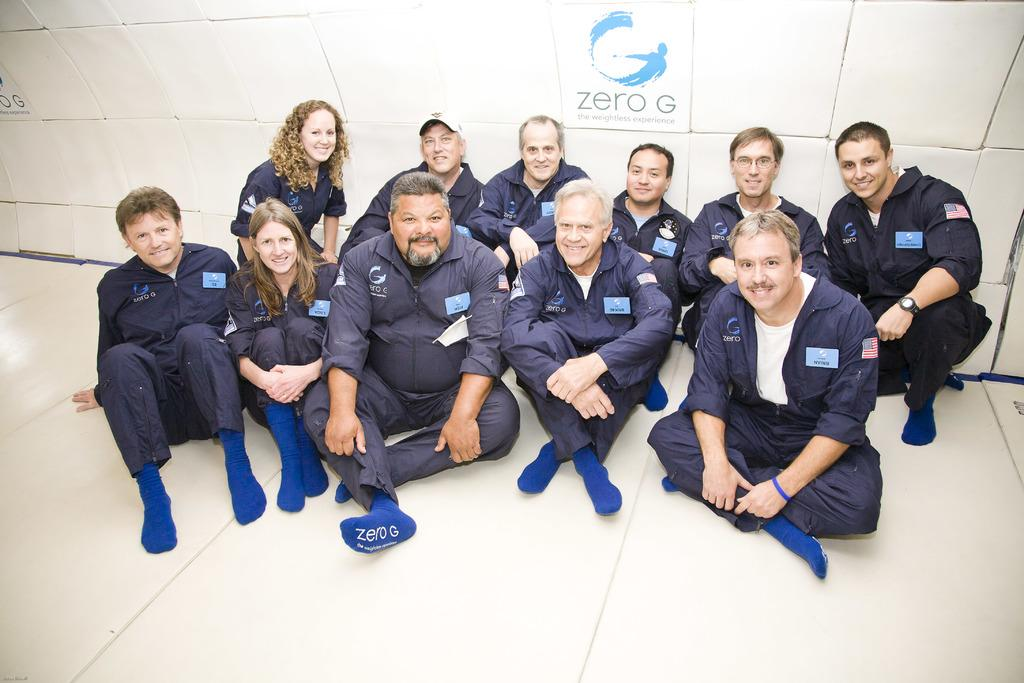How many people are in the image? There are persons in the image, but the exact number is not specified. What are the persons wearing? The persons are wearing clothes. Where are the persons sitting? The persons are sitting in front of a wall. What is at the top of the image? There is a board at the top of the image. What type of plant is growing on the wall behind the persons? There is no plant visible in the image; the persons are sitting in front of a wall. 